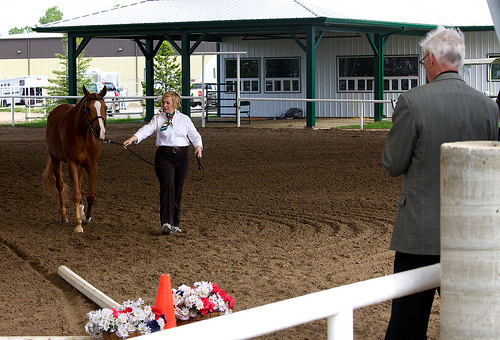<image>
Can you confirm if the person is behind the horse? No. The person is not behind the horse. From this viewpoint, the person appears to be positioned elsewhere in the scene. Is there a horse to the right of the woman? Yes. From this viewpoint, the horse is positioned to the right side relative to the woman. 